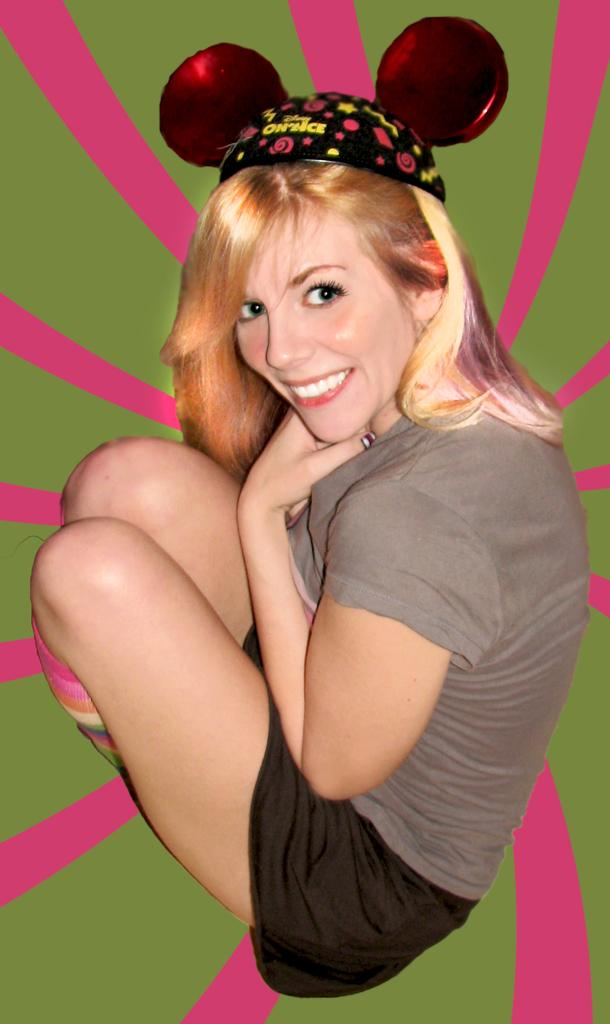What can be seen in the image? There is a person in the image. What is the person wearing? The person is wearing a brown shirt and black pants. What can be seen behind the person? There is a colored background in the image. How much profit did the person make in the image? There is no information about profit in the image, as it focuses on the person's appearance and the background. 